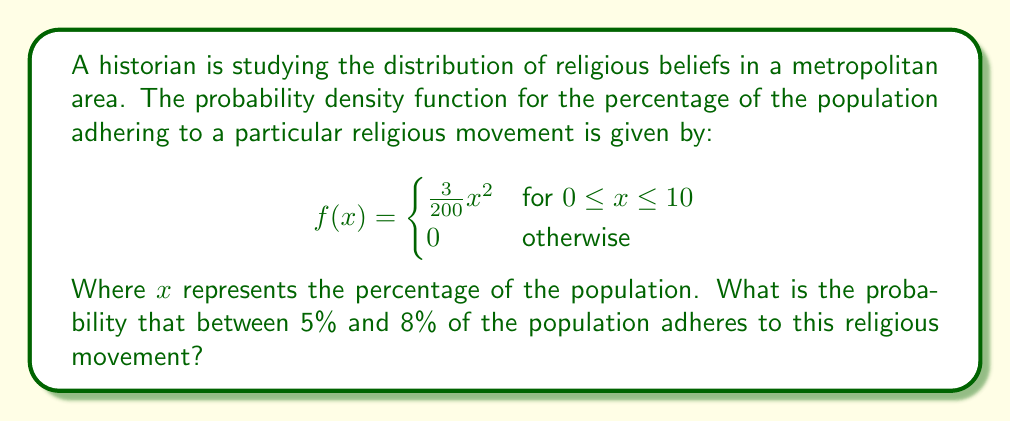Show me your answer to this math problem. To solve this problem, we need to integrate the probability density function between the given limits. Here's the step-by-step solution:

1) The probability is given by the integral of the function between 5 and 8:

   $$P(5 \leq x \leq 8) = \int_{5}^{8} f(x) dx$$

2) Substituting the given function:

   $$P(5 \leq x \leq 8) = \int_{5}^{8} \frac{3}{200}x^2 dx$$

3) Integrate the function:

   $$P(5 \leq x \leq 8) = \frac{3}{200} \cdot \frac{x^3}{3} \bigg|_{5}^{8}$$

4) Evaluate the integral:

   $$P(5 \leq x \leq 8) = \frac{1}{200} \cdot (8^3 - 5^3)$$

5) Calculate the result:

   $$P(5 \leq x \leq 8) = \frac{1}{200} \cdot (512 - 125) = \frac{387}{200} = 1.935$$

Therefore, the probability that between 5% and 8% of the population adheres to this religious movement is 0.1935 or 19.35%.
Answer: 0.1935 